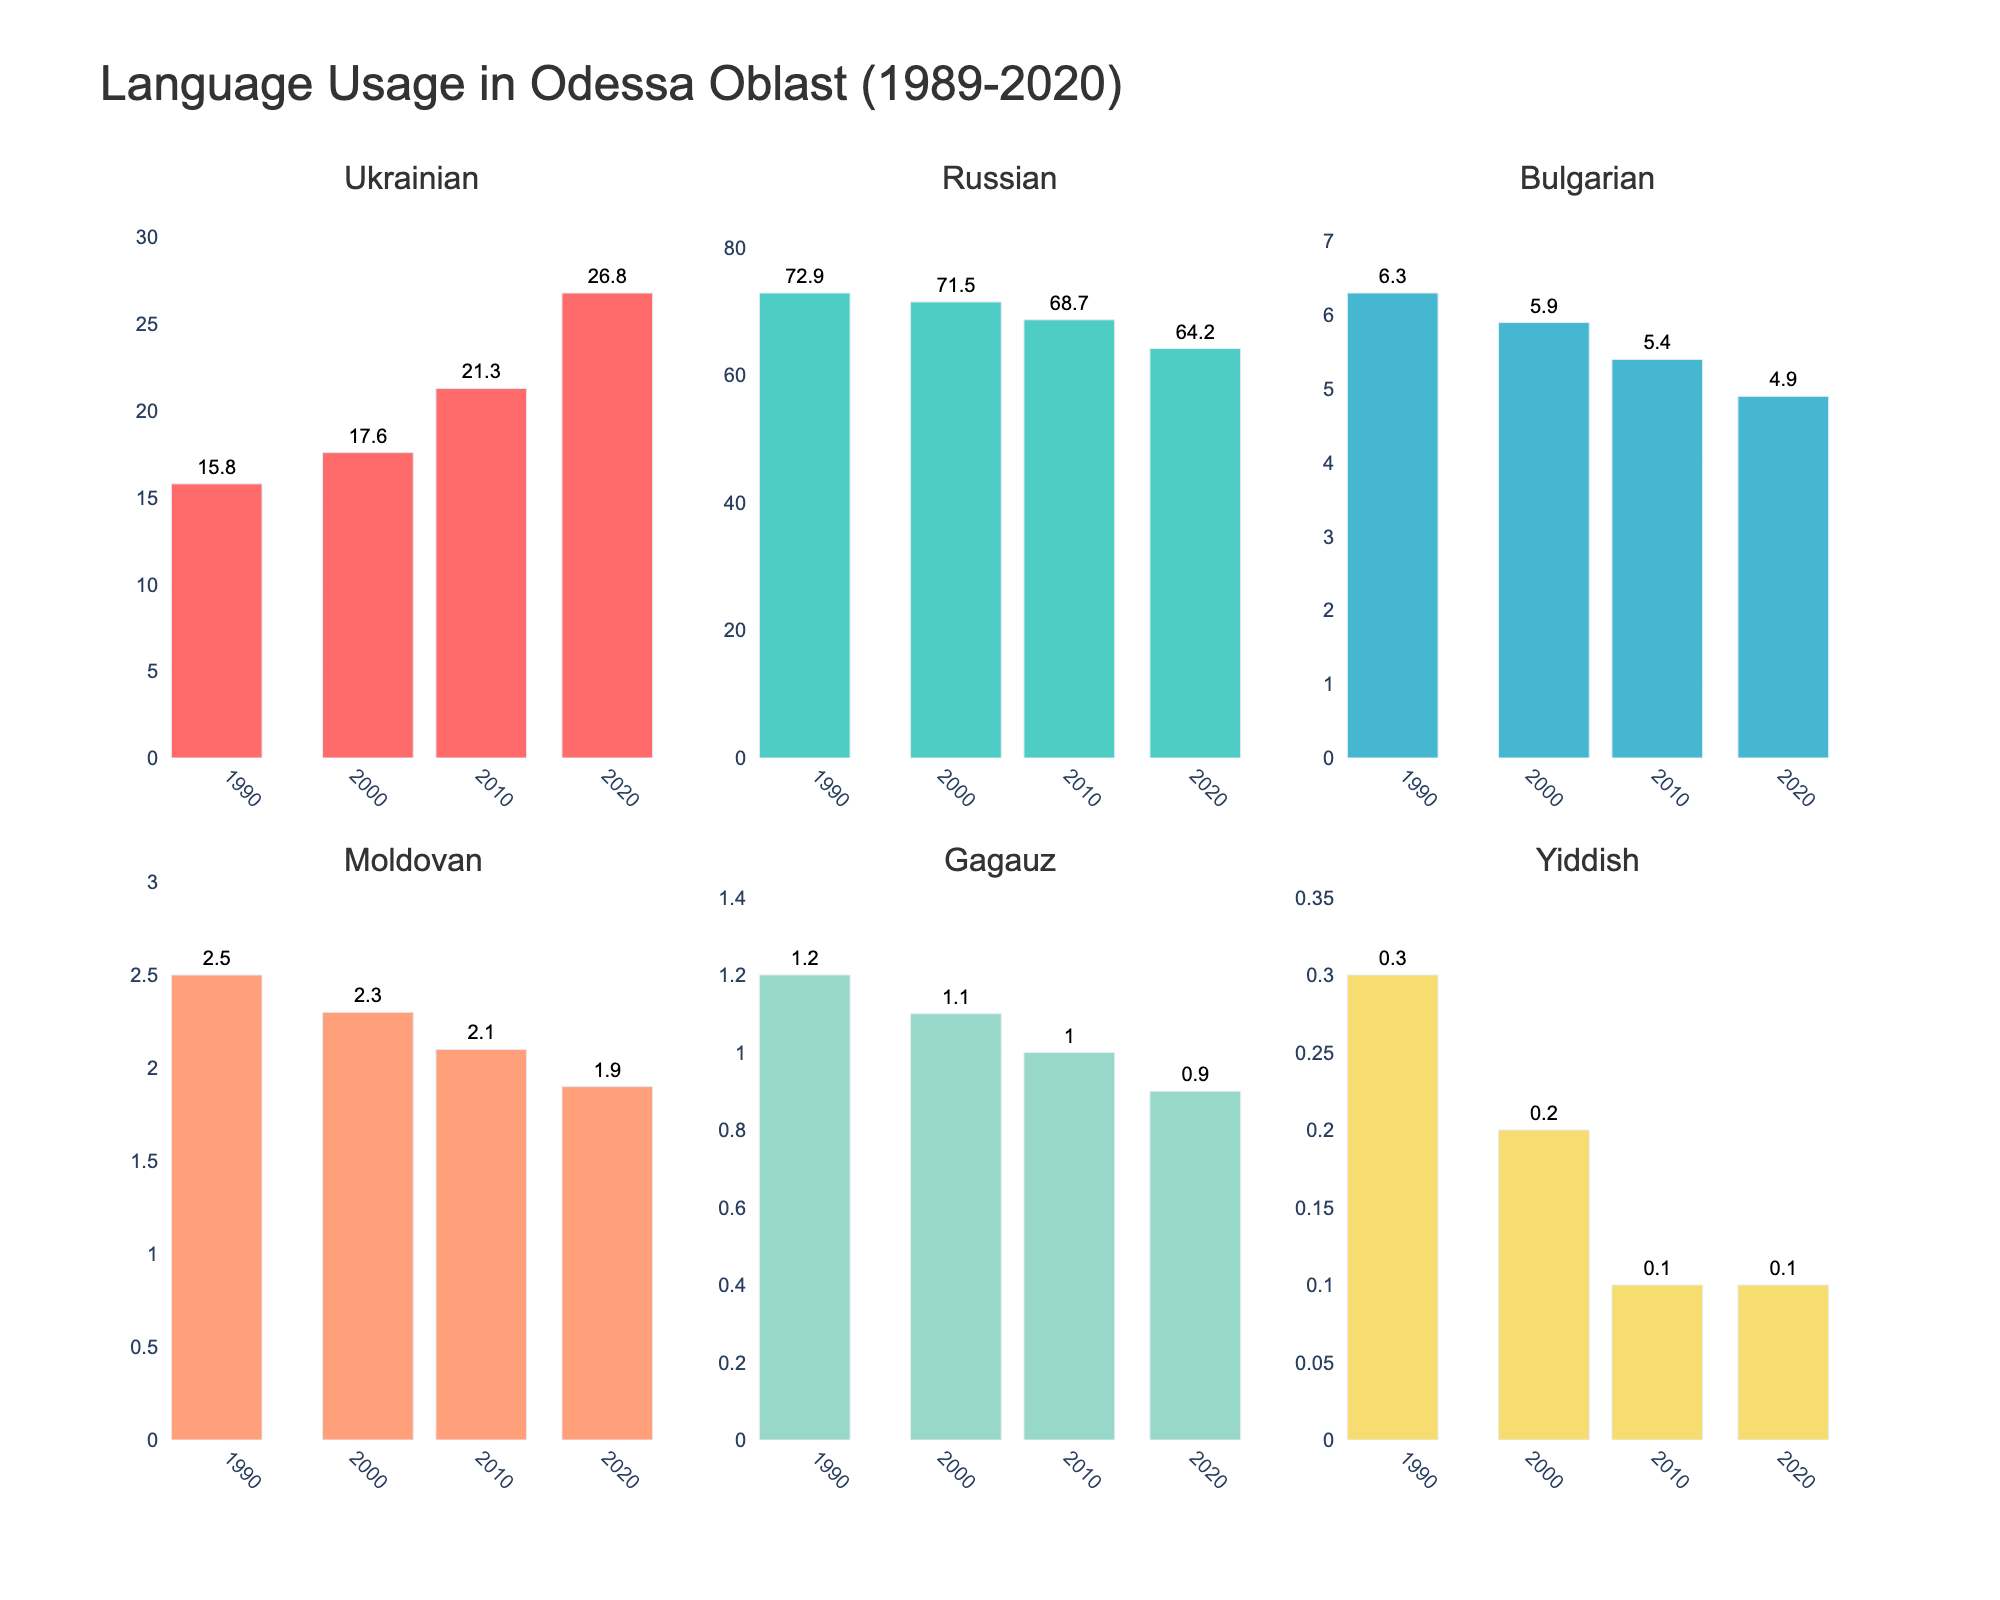what is the title of the figure? The title is displayed at the top of the figure in larger and bolder font compared to other text.
Answer: Language Usage in Odessa Oblast (1989-2020) What year had the lowest percentage of Russian spoken at home? By looking at the `Russian` subplot, we see that the bars represent percentages over different years, with the shortest bar indicating the lowest percentage. The percentage is lowest in the year 2020.
Answer: 2020 Which language showed a consistent increase in spoken usage from 1989 to 2020? Observing each subplot, we note the trend of bars from 1989 to 2020. Only the `Ukrainian` subplot shows a consistent increase in the length of bars over the years.
Answer: Ukrainian What's the combined percentage of Ukrainian and Bulgarian languages spoken at home in 2010? Referring to the `Ukrainian` and `Bulgarian` subplots for the year 2010, the percentages are 21.3% and 5.4%, respectively. Summing them up gives 21.3 + 5.4 = 26.7%.
Answer: 26.7% How did the percentage of Moldovan spoken at home change from 1989 to 2020? Check the `Moldovan` subplot to compare the bars for 1989 and 2020. The percentage drops from 2.5% in 1989 to 1.9% in 2020. The change is 1.9 - 2.5 = -0.6%.
Answer: Decreased by 0.6% In 2001, which language had the third-highest percentage of use at home and what was that percentage? By examining the subplots for the year 2001, we note the order of the bars' heights: Russian, Ukrainian, and then Bulgarian. The third-highest percentage is for Bulgarian at 5.9%.
Answer: Bulgarian, 5.9% Which language showed a decrease in spoken usage every year recorded? Observing the trends in all subplots, `Russian` is the only language with bars decreasing every year from 1989 to 2020.
Answer: Russian Is there any language that remained under 1% usage at home throughout the years 1989 to 2020? Checking each subplot, `Yiddish` consistently shows percentages below 1% for all given years.
Answer: Yiddish What is the average percentage of Gagauz spoken at home from 1989 to 2020? Sum the percentages of `Gagauz` for the years given and divide by the number of years: (1.2 + 1.1 + 1 + 0.9) / 4.
Answer: 1.05% What's the difference in percentage points between Ukrainian and Russian spoken at home in 2020? From the `Ukrainian` and `Russian` subplots for the year 2020, the percentages are 26.8% and 64.2%, respectively. The difference is 64.2 - 26.8 = 37.4 percentage points.
Answer: 37.4 